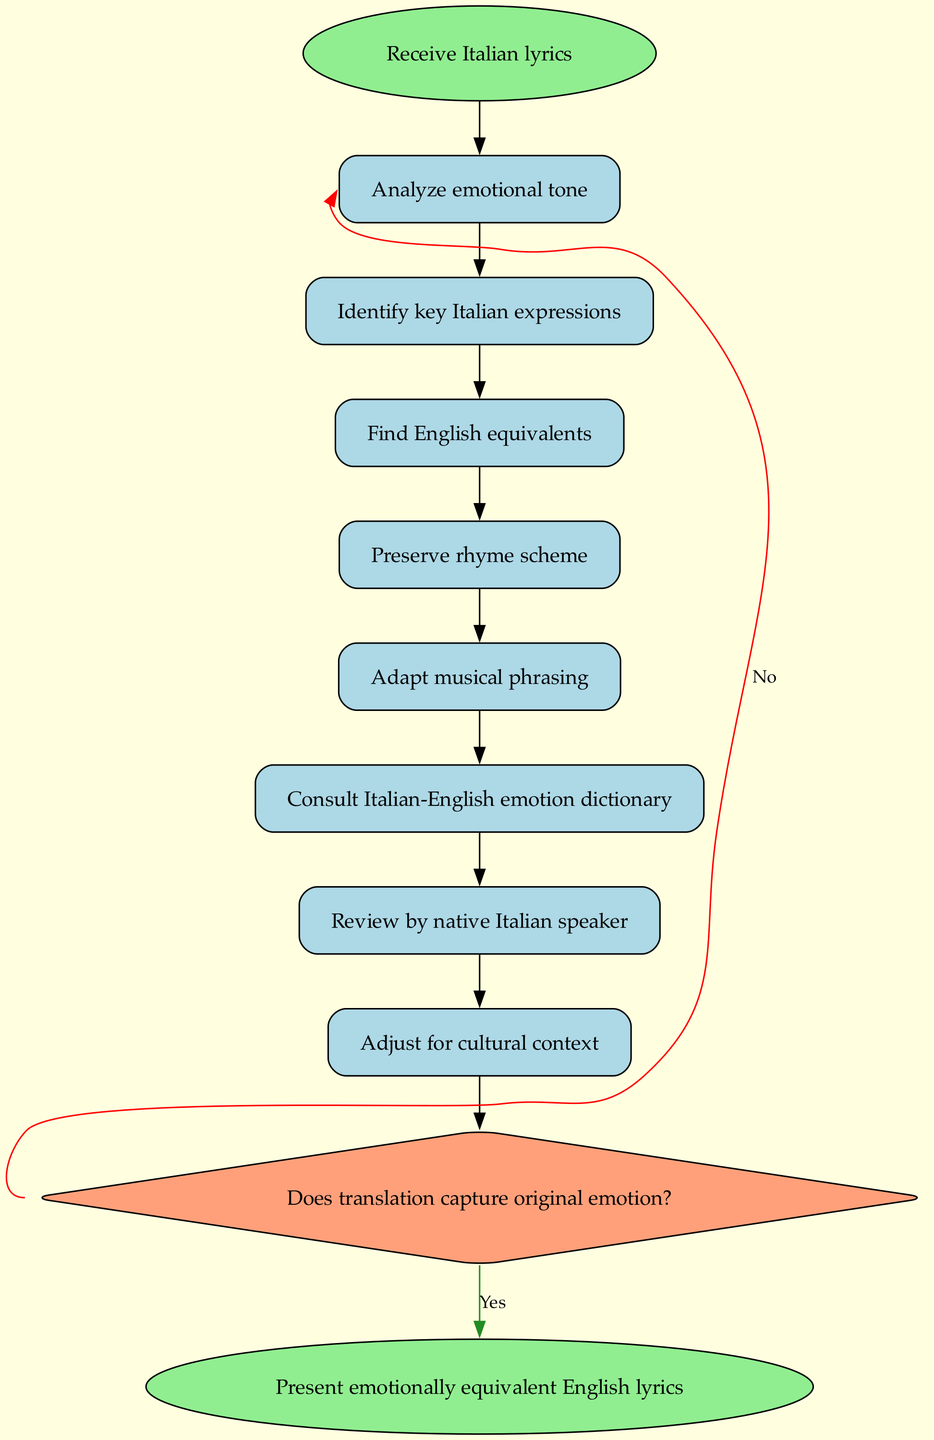What is the starting point of the flowchart? The flowchart begins with the "Receive Italian lyrics" node, which indicates the initial step of the translation process.
Answer: Receive Italian lyrics How many steps are there in the process? The flowchart identifies eight specific steps that need to be followed in the translation process.
Answer: 8 What is the last step before the decision node? The last step leading up to the decision node is "Adjust for cultural context," which comes right before evaluating the emotional capture of the translation.
Answer: Adjust for cultural context What happens if the answer to the decision question is 'Yes'? If the translation captures the original emotion, the process moves directly to the finalization of English lyrics.
Answer: Finalize English lyrics What is the decision question in the flowchart? The decision question posed in the flowchart is "Does translation capture original emotion?" which determines the next course of action based on the emotional fidelity of the translation.
Answer: Does translation capture original emotion? How many nodes are in total in the flowchart? The flowchart contains a total of ten nodes: one start, eight steps, one decision, and one end node.
Answer: 10 Which step directly follows "Find English equivalents"? The step that directly follows "Find English equivalents" in the flowchart is "Preserve rhyme scheme," indicating the order of operations for the translation.
Answer: Preserve rhyme scheme What do the edges between the nodes represent? The edges represent the flow of the process, connecting the various steps and decisions together to indicate progression through the translation algorithm.
Answer: Flow of the process What type of node is the decision node? The decision node is shaped like a diamond, which is typical in flowcharts to represent a choice that impacts the subsequent steps.
Answer: Diamond 